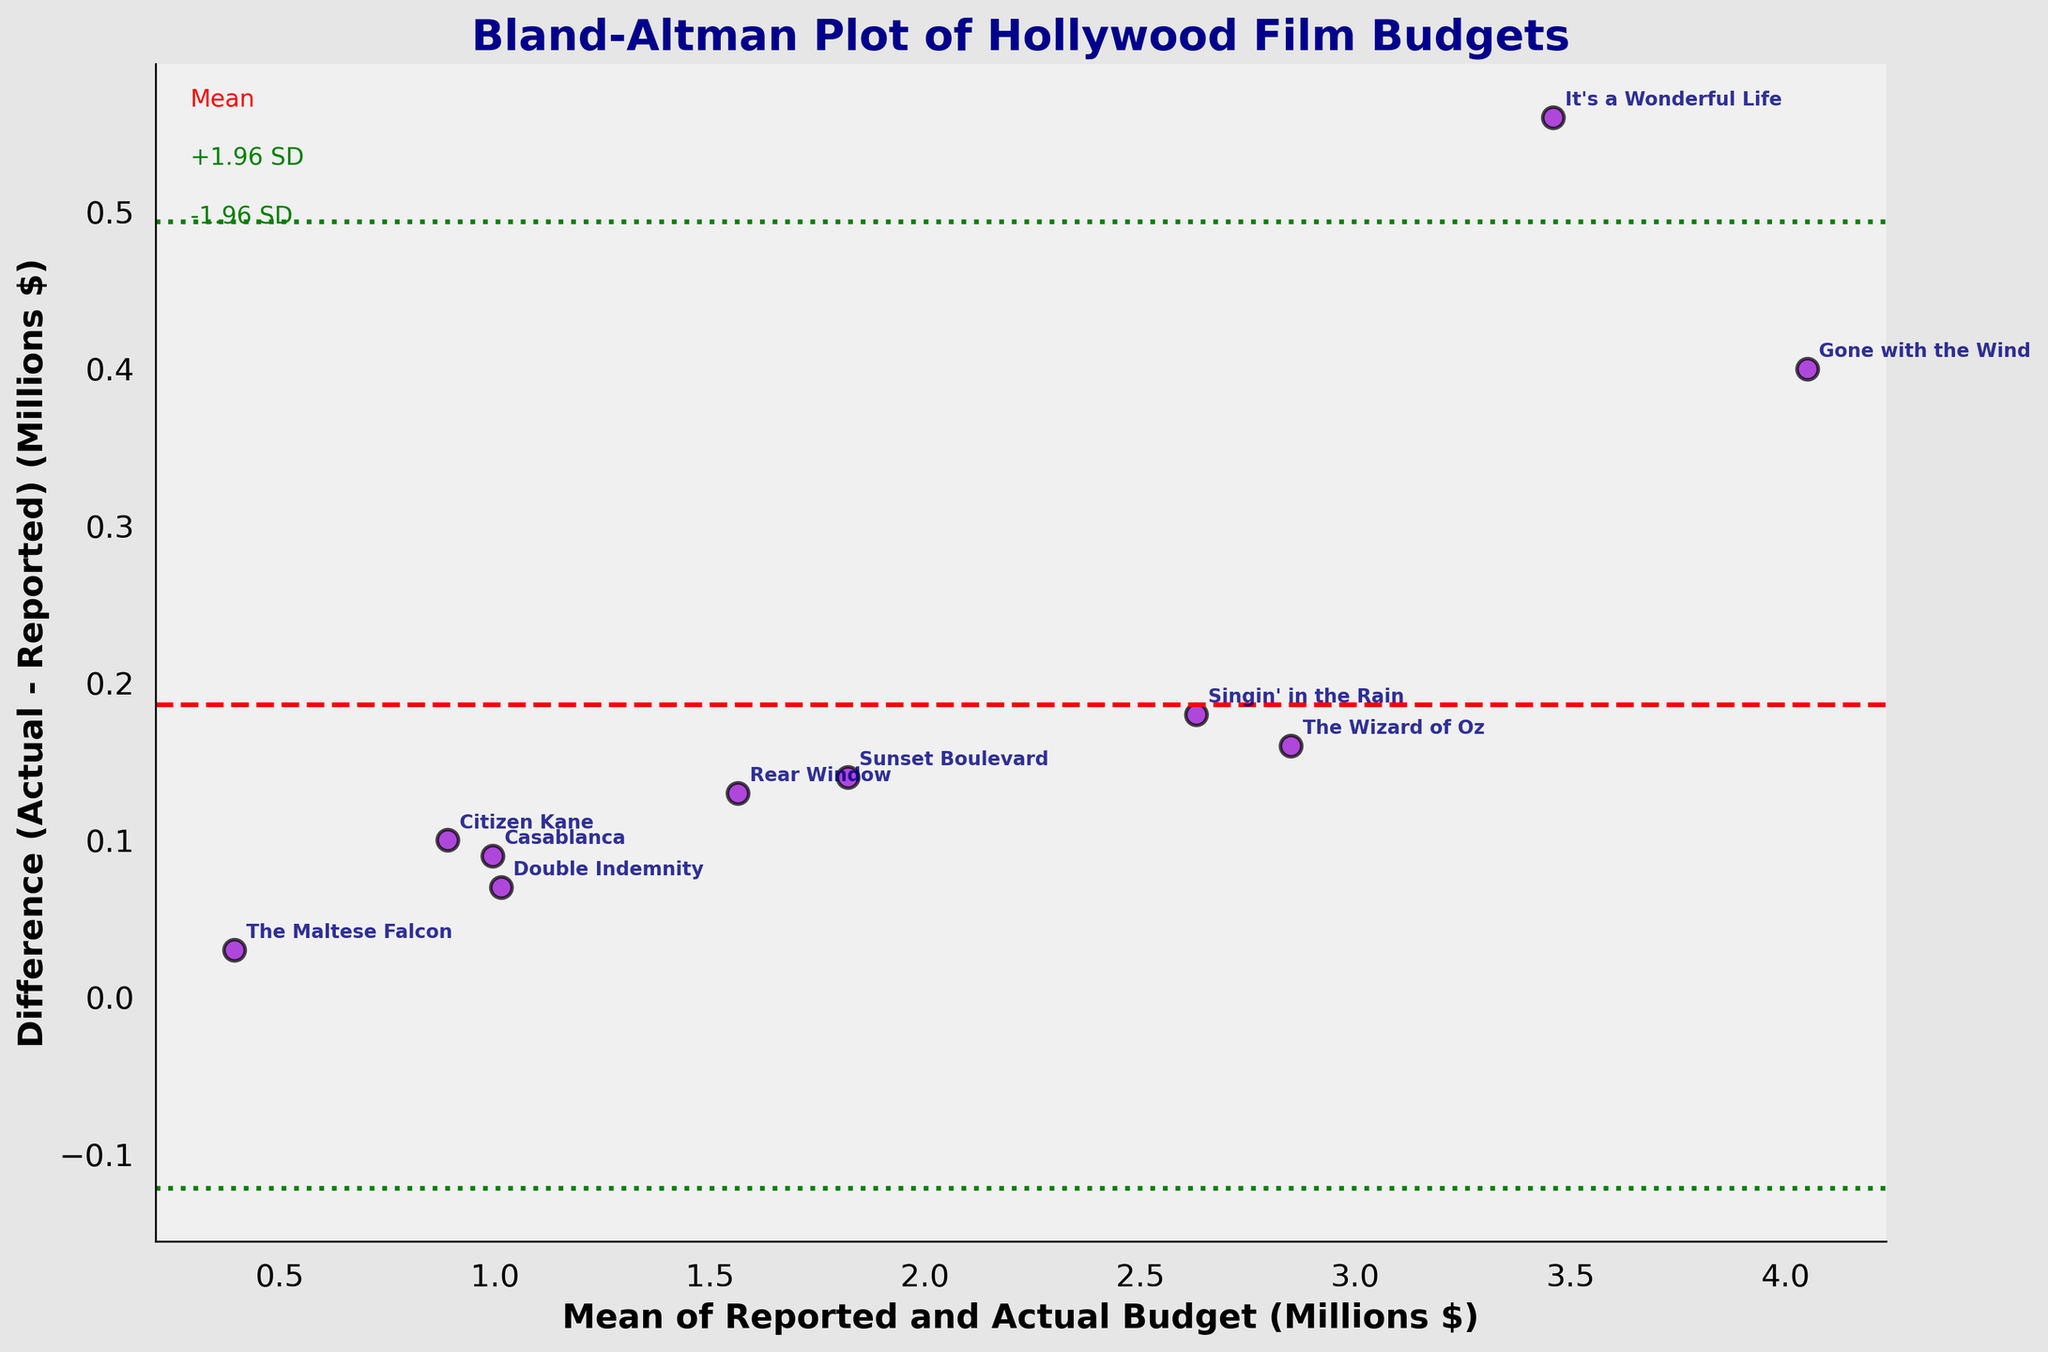Which film has the smallest budget difference between reported and actual costs? By examining the annotations around the points for the smallest differences on the y-axis, we see that The Maltese Falcon has the smallest budget difference.
Answer: The Maltese Falcon What's the title of the plot? The title is directly at the top center of the figure and reads 'Bland-Altman Plot of Hollywood Film Budgets'.
Answer: Bland-Altman Plot of Hollywood Film Budgets How many data points are on the plot? Counting each scattered point on the plot, we find there are 10 data points.
Answer: 10 What color is used for the points representing films? The points are represented with a dark violet color, as visually noted in the figure.
Answer: dark violet What is the mean difference in budget shown by the horizontal dashed line? The red dashed line indicates the mean difference, which is approximately visually centered at 0.18 millions.
Answer: ~0.18 millions Which film has the greatest actual cost compared to the reported budget? By observing the vertical difference between data points and the x-axis, It's a Wonderful Life is annotated with the largest positive difference, around 0.56 million dollars.
Answer: It's a Wonderful Life What color represents the limits of agreement (±1.96 SD) lines? These boundaries are presented with dotted green lines, as visually shown in the figure.
Answer: green What's the mean budget (in millions) for the film 'Rear Window'? Locate 'Rear Window' at point (1.565, 0.13) on the plot, and the x-value represents the mean budget.
Answer: 1.565 Are there more films with a positive or negative budget difference between reported and actual costs? By counting the points above and below the notional zero line on the y-axis, there are more points above zero, indicating more films with positive budget differences.
Answer: more films with positive budget differences What shape is used to represent data points on the plot? The plot uses circles to represent each data point, noted by their rounded appearance and edges.
Answer: circles 